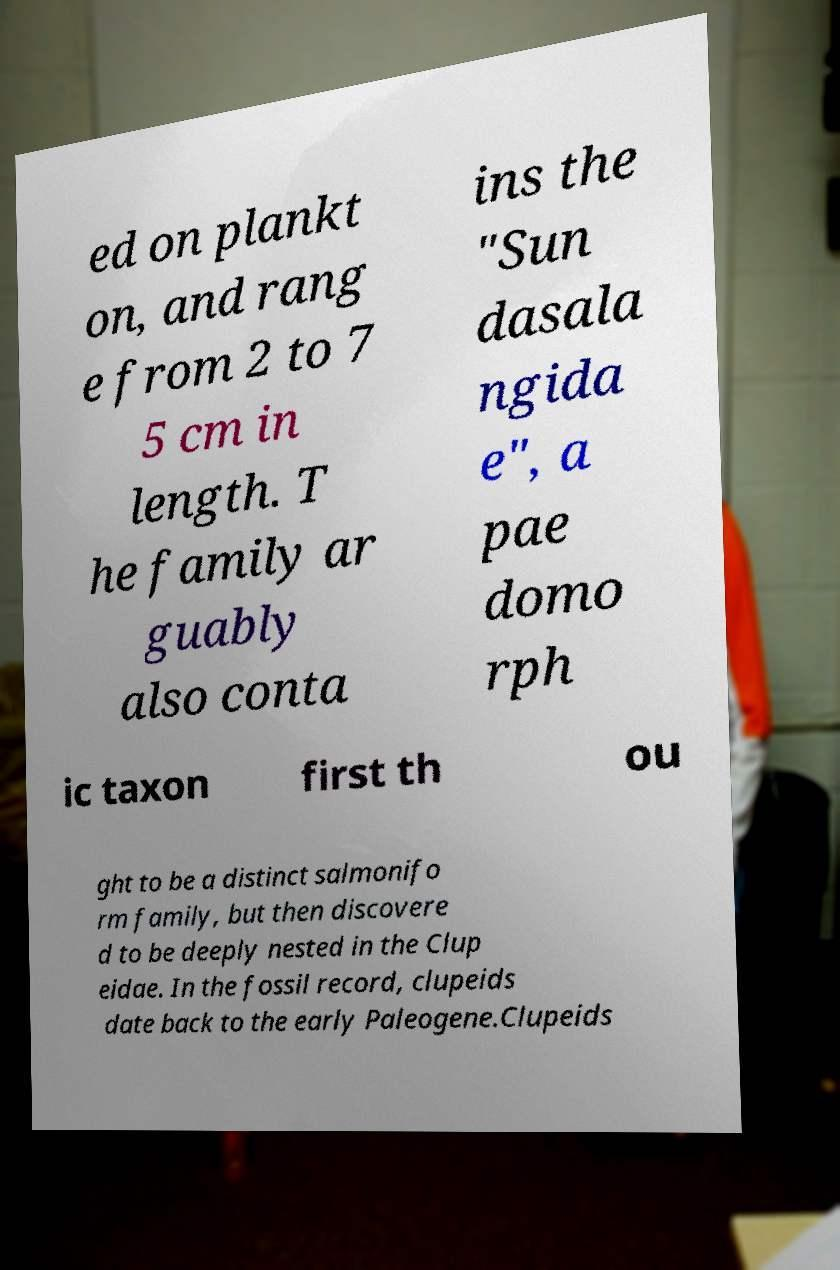For documentation purposes, I need the text within this image transcribed. Could you provide that? ed on plankt on, and rang e from 2 to 7 5 cm in length. T he family ar guably also conta ins the "Sun dasala ngida e", a pae domo rph ic taxon first th ou ght to be a distinct salmonifo rm family, but then discovere d to be deeply nested in the Clup eidae. In the fossil record, clupeids date back to the early Paleogene.Clupeids 